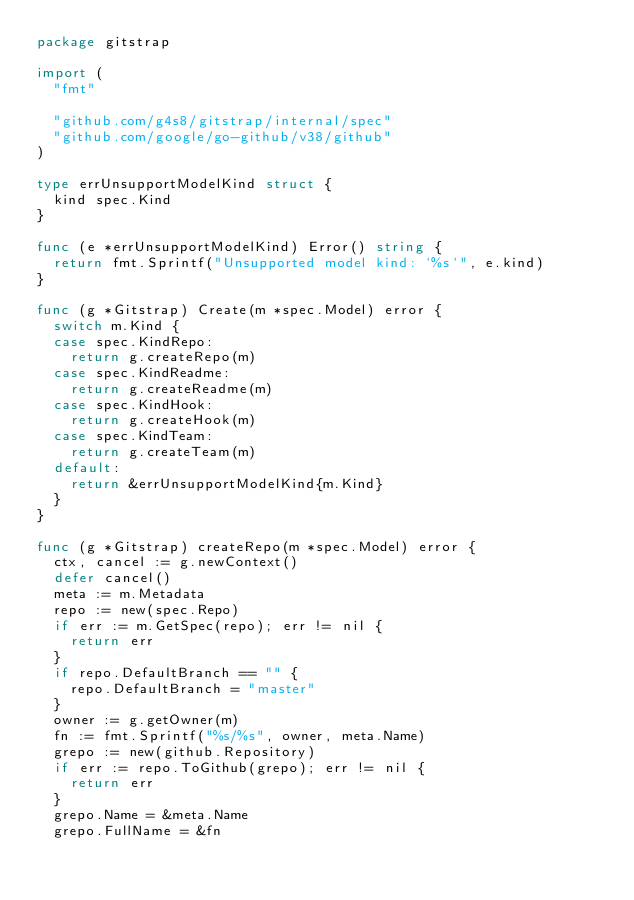<code> <loc_0><loc_0><loc_500><loc_500><_Go_>package gitstrap

import (
	"fmt"

	"github.com/g4s8/gitstrap/internal/spec"
	"github.com/google/go-github/v38/github"
)

type errUnsupportModelKind struct {
	kind spec.Kind
}

func (e *errUnsupportModelKind) Error() string {
	return fmt.Sprintf("Unsupported model kind: `%s`", e.kind)
}

func (g *Gitstrap) Create(m *spec.Model) error {
	switch m.Kind {
	case spec.KindRepo:
		return g.createRepo(m)
	case spec.KindReadme:
		return g.createReadme(m)
	case spec.KindHook:
		return g.createHook(m)
	case spec.KindTeam:
		return g.createTeam(m)
	default:
		return &errUnsupportModelKind{m.Kind}
	}
}

func (g *Gitstrap) createRepo(m *spec.Model) error {
	ctx, cancel := g.newContext()
	defer cancel()
	meta := m.Metadata
	repo := new(spec.Repo)
	if err := m.GetSpec(repo); err != nil {
		return err
	}
	if repo.DefaultBranch == "" {
		repo.DefaultBranch = "master"
	}
	owner := g.getOwner(m)
	fn := fmt.Sprintf("%s/%s", owner, meta.Name)
	grepo := new(github.Repository)
	if err := repo.ToGithub(grepo); err != nil {
		return err
	}
	grepo.Name = &meta.Name
	grepo.FullName = &fn</code> 